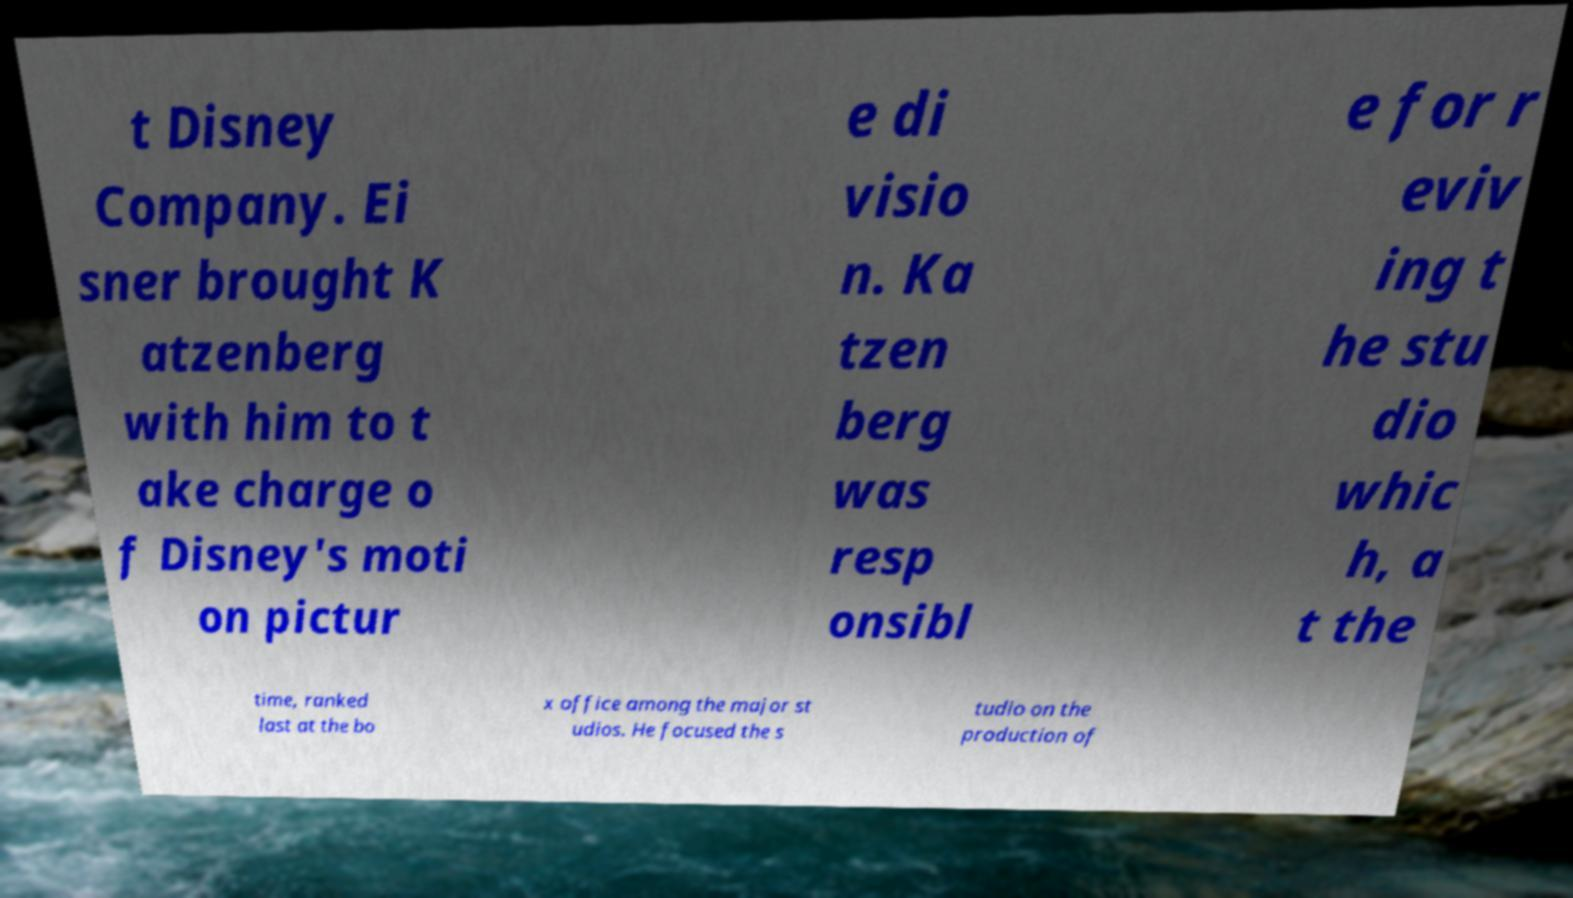Could you extract and type out the text from this image? t Disney Company. Ei sner brought K atzenberg with him to t ake charge o f Disney's moti on pictur e di visio n. Ka tzen berg was resp onsibl e for r eviv ing t he stu dio whic h, a t the time, ranked last at the bo x office among the major st udios. He focused the s tudio on the production of 